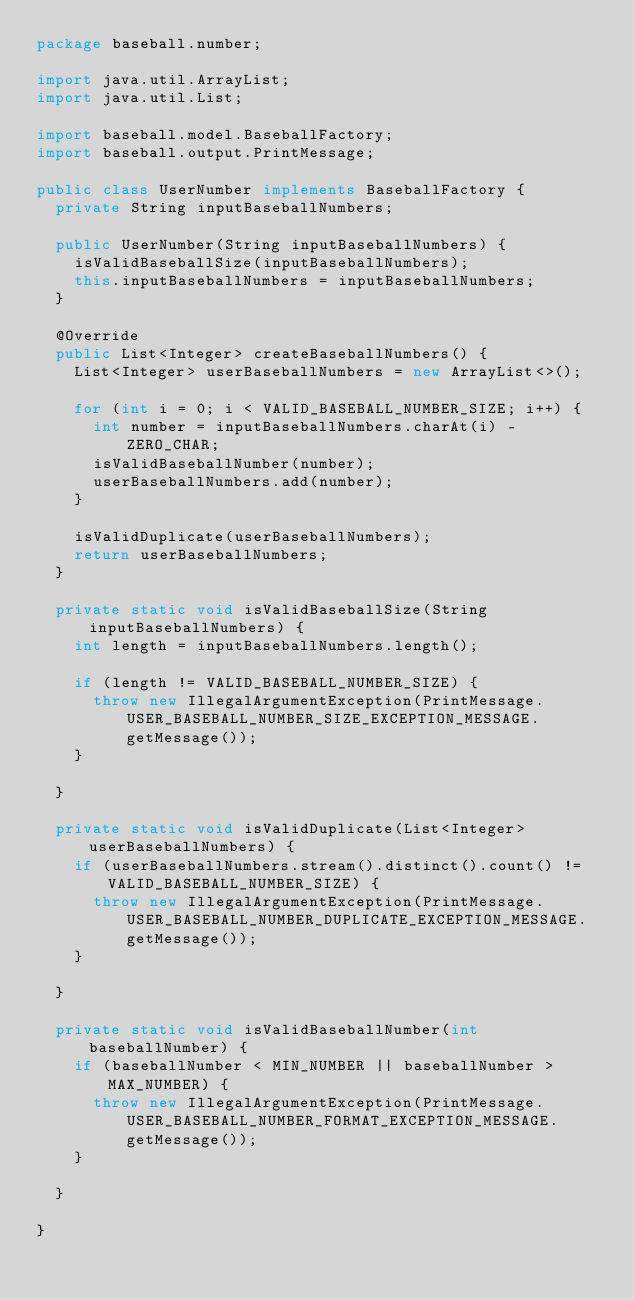<code> <loc_0><loc_0><loc_500><loc_500><_Java_>package baseball.number;

import java.util.ArrayList;
import java.util.List;

import baseball.model.BaseballFactory;
import baseball.output.PrintMessage;

public class UserNumber implements BaseballFactory {
	private String inputBaseballNumbers;

	public UserNumber(String inputBaseballNumbers) {
		isValidBaseballSize(inputBaseballNumbers);
		this.inputBaseballNumbers = inputBaseballNumbers;
	}

	@Override
	public List<Integer> createBaseballNumbers() {
		List<Integer> userBaseballNumbers = new ArrayList<>();

		for (int i = 0; i < VALID_BASEBALL_NUMBER_SIZE; i++) {
			int number = inputBaseballNumbers.charAt(i) - ZERO_CHAR;
			isValidBaseballNumber(number);
			userBaseballNumbers.add(number);
		}

		isValidDuplicate(userBaseballNumbers);
		return userBaseballNumbers;
	}

	private static void isValidBaseballSize(String inputBaseballNumbers) {
		int length = inputBaseballNumbers.length();

		if (length != VALID_BASEBALL_NUMBER_SIZE) {
			throw new IllegalArgumentException(PrintMessage.USER_BASEBALL_NUMBER_SIZE_EXCEPTION_MESSAGE.getMessage());
		}

	}

	private static void isValidDuplicate(List<Integer> userBaseballNumbers) {
		if (userBaseballNumbers.stream().distinct().count() != VALID_BASEBALL_NUMBER_SIZE) {
			throw new IllegalArgumentException(PrintMessage.USER_BASEBALL_NUMBER_DUPLICATE_EXCEPTION_MESSAGE.getMessage());
		}

	}

	private static void isValidBaseballNumber(int baseballNumber) {
		if (baseballNumber < MIN_NUMBER || baseballNumber > MAX_NUMBER) {
			throw new IllegalArgumentException(PrintMessage.USER_BASEBALL_NUMBER_FORMAT_EXCEPTION_MESSAGE.getMessage());
		}

	}

}
</code> 